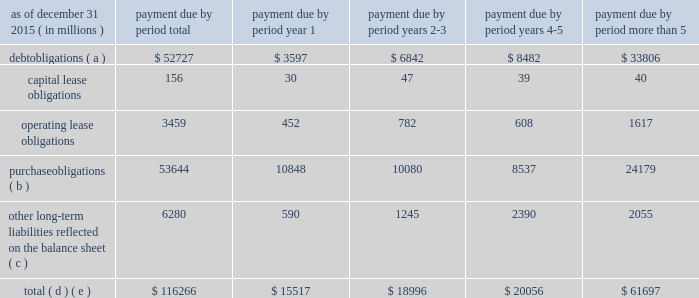The table below sets forth information on our share repurchases and dividends paid in 2015 , 2014 and 2013 .
( in billions ) share repurchases and dividends paid dividends paid share repurchases 20142013 2015 contractual obligations .
Purchase obligations ( b ) 53644 10848 10080 8537 24179 other long-term liabilities reflected on the balance sheet ( c ) 6280 590 1245 2390 2055 total ( d ) ( e ) $ 116266 $ 15517 $ 18996 $ 20056 $ 61697 refer to note 10 and note 17 to comcast 2019s consolidated financial statements .
( a ) excludes interest payments .
( b ) purchase obligations consist of agreements to purchase goods and services that are legally binding on us and specify all significant terms , including fixed or minimum quantities to be purchased and price provisions .
Our purchase obligations related to our cable communications segment include programming contracts with cable networks and local broadcast television stations ; contracts with customer premise equipment manufacturers , communications vendors and multichannel video providers for which we provide advertising sales representation ; and other contracts entered into in the normal course of business .
Cable communications programming contracts in the table above include amounts payable under fixed or minimum guaranteed commitments and do not represent the total fees that are expected to be paid under programming contracts , which we expect to be significantly higher because these contracts are generally based on the number of subscribers receiving the programming .
Our purchase obligations related to our nbcuniversal segments consist primarily of commitments to acquire film and television programming , including u.s .
Television rights to future olympic games through 2032 , sunday night football on the nbc network through the 2022-23 season , including the super bowl in 2018 and 2021 , nhl games through the 2020-21 season , spanish-language u.s .
Television rights to fifa world cup games through 2022 , u.s television rights to english premier league soccer games through the 2021-22 season , certain pga tour and other golf events through 2030 and certain nascar events through 2024 , as well as obligations under various creative talent and employment agreements , including obligations to actors , producers , television personalities and executives , and various other television commitments .
Purchase obligations do not include contracts with immaterial future commitments .
( c ) other long-term liabilities reflected on the balance sheet consist primarily of subsidiary preferred shares ; deferred compensation obliga- tions ; and pension , postretirement and postemployment benefit obligations .
A contractual obligation with a carrying value of $ 1.1 billion is not included in the table above because it is uncertain if the arrangement will be settled .
The contractual obligation involves an interest held by a third party in the revenue of certain theme parks .
The arrangement provides the counterparty with the right to periodic pay- ments associated with current period revenue and , beginning in 2017 , the option to require nbcuniversal to purchase the interest for cash in an amount based on a contractually specified formula , which amount could be significantly higher than our current carrying value .
See note 11 to comcast 2019s consolidated financial statements for additional information related to this arrangement .
Reserves for uncertain tax positions of $ 1.1 billion are not included in the table above because it is uncertain if and when these reserves will become payable .
Payments of $ 2.1 billion of participations and residuals are also not included in the table above because we cannot make a reliable esti- mate of the period in which these obligations will be settled .
( d ) our contractual obligations do not include the commitment to invest up to $ 4 billion at any one time as an investor in atairos due to our inability to estimate the timing of this funding .
In addition , we do not include any future expenditures related to the construction and development of the proposed universal studios theme park in beijing , china as we are not currently obligated to make such funding .
Comcast 2015 annual report on form 10-k 66 .
What percent of total payments due in year 1 are due to purchase obligations? 
Computations: (10848 / 15517)
Answer: 0.6991. 